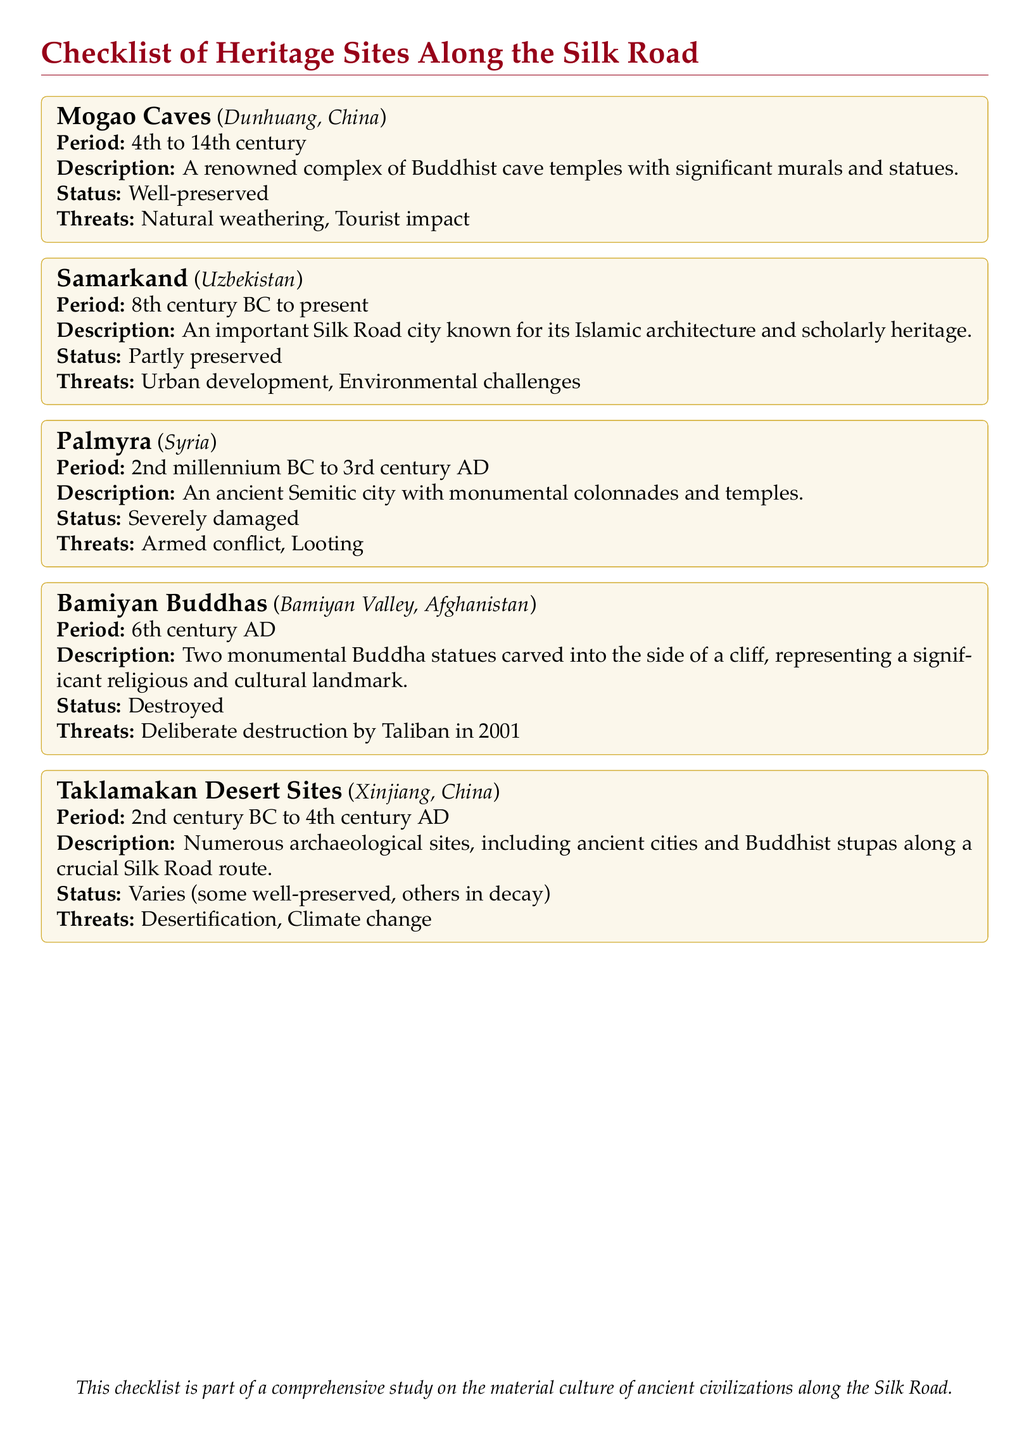What is the location of the Mogao Caves? The location of the Mogao Caves is provided in the document as Dunhuang, China.
Answer: Dunhuang, China What century do the Mogao Caves date back to? The document states that the Mogao Caves date from the 4th to the 14th century.
Answer: 4th to 14th century What is the preservation status of Samarkand? The document indicates that the preservation status of Samarkand is partly preserved.
Answer: Partly preserved What are the primary threats to the Palmyra site? The document lists armed conflict and looting as the primary threats to Palmyra.
Answer: Armed conflict, Looting Were the Bamiyan Buddhas preserved? According to the document, the Bamiyan Buddhas were destroyed, indicating they were not preserved.
Answer: Destroyed What type of archaeological sites are found in the Taklamakan Desert? The document specifies that numerous archaeological sites, including ancient cities and Buddhist stupas, are found in the Taklamakan Desert.
Answer: Ancient cities and Buddhist stupas What significant action occurred in 2001 regarding the Bamiyan Buddhas? The document states that the significant action was deliberate destruction by the Taliban in 2001.
Answer: Deliberate destruction by Taliban in 2001 What period does the Taklamakan Desert Sites cover? The period for the Taklamakan Desert Sites is indicated in the document as the 2nd century BC to the 4th century AD.
Answer: 2nd century BC to 4th century AD What is the color scheme used for the heading in the document? The document describes the color scheme of the heading as silkred.
Answer: silkred 